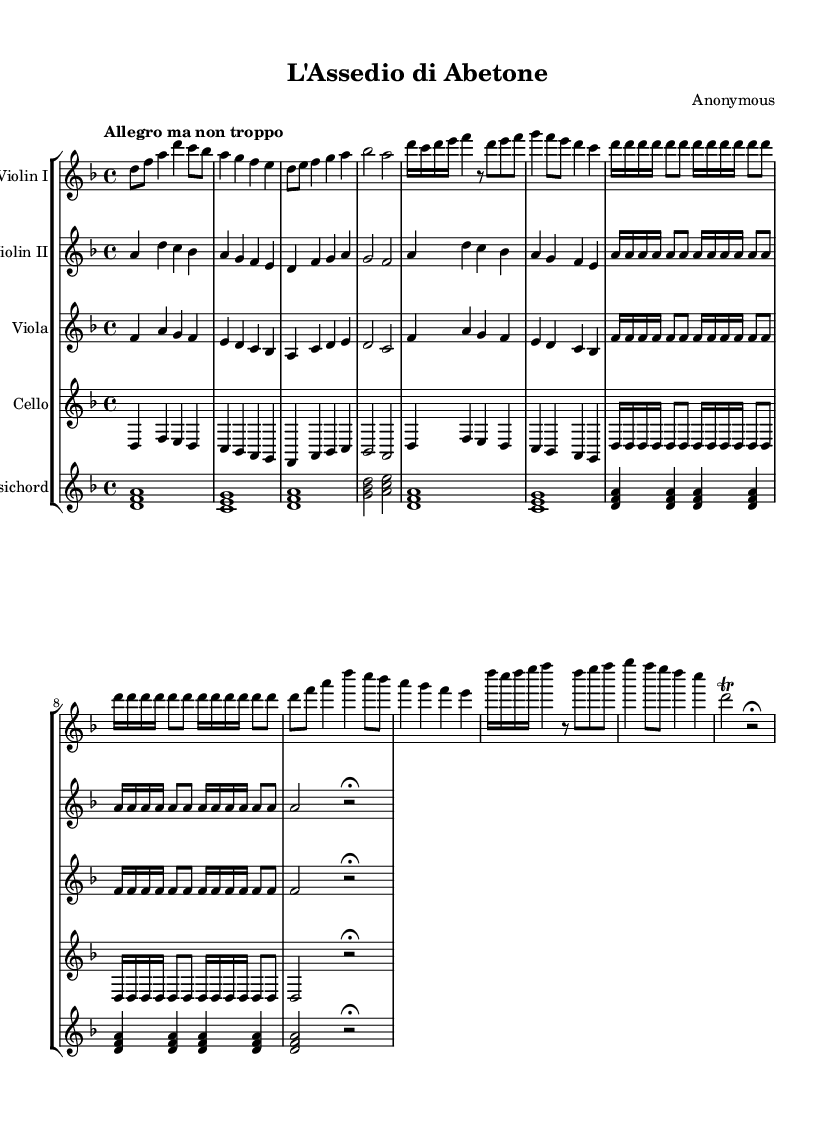What is the key signature of this music? The key signature indicated at the beginning of the score shows two flats, which indicates D minor.
Answer: D minor What is the time signature of the piece? The time signature is found at the beginning of the score after the key signature. It shows 4 beats per measure, represented by 4/4.
Answer: 4/4 What is the tempo marking of the music? The tempo marking is indicated at the start of the score. It states "Allegro ma non troppo," meaning fast but not too fast.
Answer: Allegro ma non troppo How many themes are presented in the piece? By analyzing the score, we can identify three distinct themes (Theme A, Theme B, and Theme C) that are labeled within the music.
Answer: Three What is the structure of the piece based on the themes? The structure involves an Introduction, Theme A, Theme B, Theme A', Theme C, and a Coda. This outlines how the music progresses through its sections.
Answer: Introduction, A, B, A', C, Coda What character does Theme B represent? Theme B is labeled as “Skirmish,” suggesting that it depicts a chaotic or fast-paced section resembling the skirmishes in battle.
Answer: Skirmish What instruments are included in the score? The score lists five instruments: Violin I, Violin II, Viola, Cello, and Harpsichord at the beginning of each staff.
Answer: Violin I, Violin II, Viola, Cello, Harpsichord 